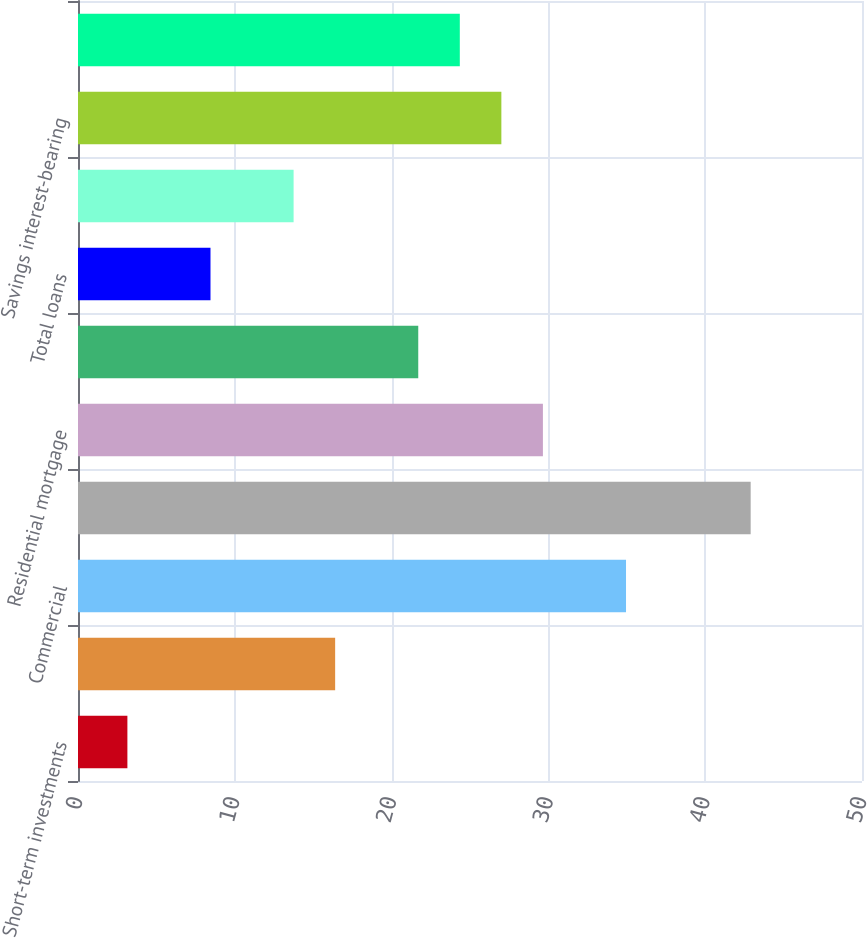Convert chart to OTSL. <chart><loc_0><loc_0><loc_500><loc_500><bar_chart><fcel>Short-term investments<fcel>Securities<fcel>Commercial<fcel>Commercial real estate<fcel>Residential mortgage<fcel>Consumer<fcel>Total loans<fcel>Total change in interest and<fcel>Savings interest-bearing<fcel>Time<nl><fcel>3.15<fcel>16.4<fcel>34.95<fcel>42.9<fcel>29.65<fcel>21.7<fcel>8.45<fcel>13.75<fcel>27<fcel>24.35<nl></chart> 